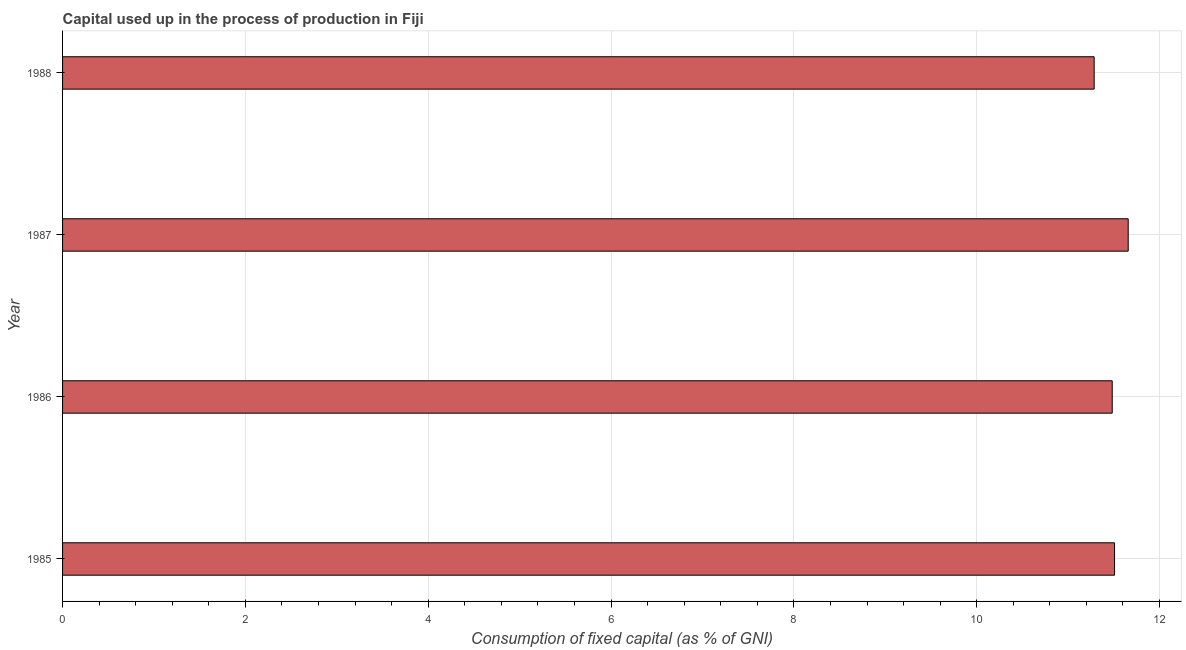What is the title of the graph?
Your answer should be compact. Capital used up in the process of production in Fiji. What is the label or title of the X-axis?
Your answer should be very brief. Consumption of fixed capital (as % of GNI). What is the consumption of fixed capital in 1986?
Your answer should be compact. 11.48. Across all years, what is the maximum consumption of fixed capital?
Your response must be concise. 11.66. Across all years, what is the minimum consumption of fixed capital?
Provide a short and direct response. 11.28. In which year was the consumption of fixed capital maximum?
Provide a succinct answer. 1987. In which year was the consumption of fixed capital minimum?
Provide a short and direct response. 1988. What is the sum of the consumption of fixed capital?
Ensure brevity in your answer.  45.93. What is the difference between the consumption of fixed capital in 1986 and 1987?
Make the answer very short. -0.17. What is the average consumption of fixed capital per year?
Your answer should be compact. 11.48. What is the median consumption of fixed capital?
Keep it short and to the point. 11.49. In how many years, is the consumption of fixed capital greater than 10 %?
Give a very brief answer. 4. Do a majority of the years between 1987 and 1988 (inclusive) have consumption of fixed capital greater than 7.6 %?
Provide a short and direct response. Yes. What is the ratio of the consumption of fixed capital in 1986 to that in 1988?
Provide a short and direct response. 1.02. What is the difference between the highest and the second highest consumption of fixed capital?
Offer a terse response. 0.15. What is the difference between the highest and the lowest consumption of fixed capital?
Your answer should be very brief. 0.37. How many bars are there?
Offer a terse response. 4. How many years are there in the graph?
Offer a terse response. 4. What is the difference between two consecutive major ticks on the X-axis?
Provide a succinct answer. 2. What is the Consumption of fixed capital (as % of GNI) of 1985?
Ensure brevity in your answer.  11.51. What is the Consumption of fixed capital (as % of GNI) in 1986?
Ensure brevity in your answer.  11.48. What is the Consumption of fixed capital (as % of GNI) in 1987?
Provide a short and direct response. 11.66. What is the Consumption of fixed capital (as % of GNI) in 1988?
Your response must be concise. 11.28. What is the difference between the Consumption of fixed capital (as % of GNI) in 1985 and 1986?
Keep it short and to the point. 0.03. What is the difference between the Consumption of fixed capital (as % of GNI) in 1985 and 1987?
Provide a succinct answer. -0.15. What is the difference between the Consumption of fixed capital (as % of GNI) in 1985 and 1988?
Keep it short and to the point. 0.22. What is the difference between the Consumption of fixed capital (as % of GNI) in 1986 and 1987?
Ensure brevity in your answer.  -0.17. What is the difference between the Consumption of fixed capital (as % of GNI) in 1986 and 1988?
Make the answer very short. 0.2. What is the difference between the Consumption of fixed capital (as % of GNI) in 1987 and 1988?
Give a very brief answer. 0.37. What is the ratio of the Consumption of fixed capital (as % of GNI) in 1985 to that in 1987?
Offer a terse response. 0.99. What is the ratio of the Consumption of fixed capital (as % of GNI) in 1986 to that in 1987?
Ensure brevity in your answer.  0.98. What is the ratio of the Consumption of fixed capital (as % of GNI) in 1986 to that in 1988?
Give a very brief answer. 1.02. What is the ratio of the Consumption of fixed capital (as % of GNI) in 1987 to that in 1988?
Offer a terse response. 1.03. 